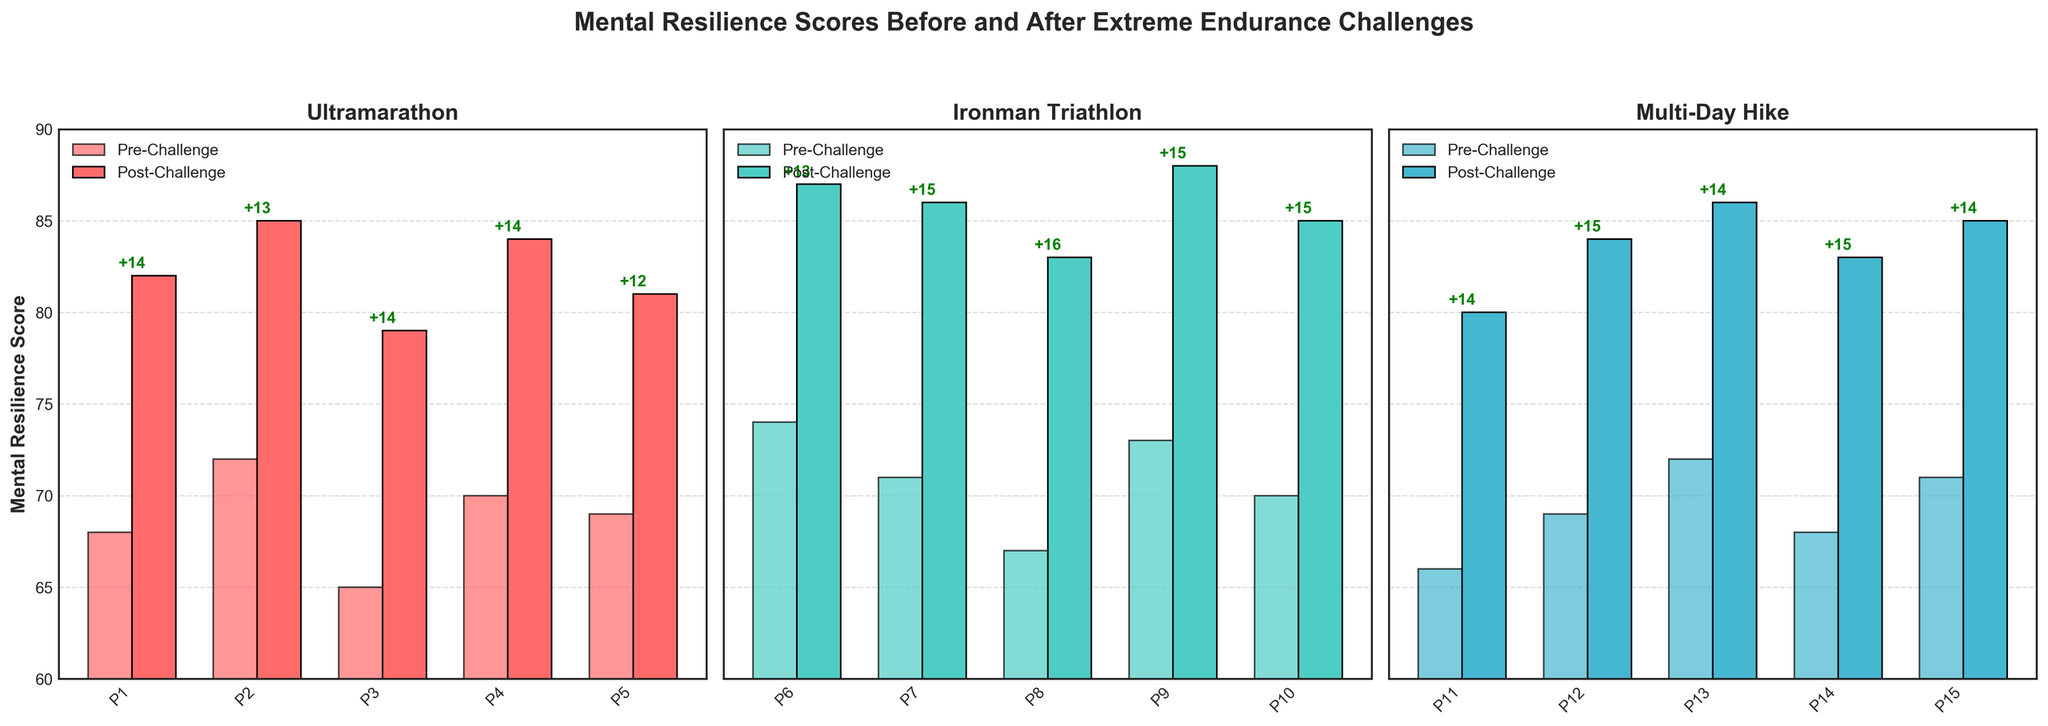Which challenge type showed the highest average improvement in mental resilience scores? First, calculate the improvement for each participant by subtracting the Pre-Challenge Score from the Post-Challenge Score. Then, find the average improvement for each challenge type. The highest average improvement will be the challenge with the largest mean increase. Ultramarathon: (82-68 + 85-72 + 79-65 + 84-70 + 81-69) / 5 = 13.8, Ironman Triathlon: (87-74 + 86-71 + 83-67 + 88-73 + 85-70) / 5 = 15.4, Multi-Day Hike: (80-66 + 84-69 + 86-72 + 83-68 + 85-71) / 5 = 13.6
Answer: Ironman Triathlon Which participant had the greatest increase in mental resilience score in the Ultramarathon challenge? Observe the 'Ultramarathon' subplot and compare the difference between Pre-Challenge and Post-Challenge scores for each participant. The participant with the highest increase is the one with the largest difference. Participants are P1: 14, P2: 13, P3: 14, P4: 14, P5: 12.
Answer: P1, P3, and P4 What is the total increase in mental resilience scores for participants in the Multi-Day Hike challenge? For each participant in the Multi-Day Hike challenge, calculate the difference between the Post-Challenge and Pre-Challenge scores, then sum these differences. (80-66) + (84-69) + (86-72) + (83-68) + (85-71) = 14 + 15 + 14 + 15 + 14 = 72
Answer: 72 Which challenge type had the smallest range of Pre-Challenge mental resilience scores among participants? Identify the range of Pre-Challenge scores for each challenge type, which is the difference between the maximum and minimum scores. Ultramarathon: Max(74), Min(65) -> Range: 9; Ironman Triathlon: Max(74), Min(67) -> Range: 7; Multi-Day Hike: Max(72), Min(66) -> Range: 6.
Answer: Multi-Day Hike Did any participant's mental resilience score decrease after the challenge? For each subgroup in the subplots, compare the Pre-Challenge and Post-Challenge scores. A decrease would be indicated if the Post-Challenge bar is shorter than the Pre-Challenge bar. None of the participants' scores decreased.
Answer: No Which challenge type has the most uniform improvement in mental resilience scores? Uniform improvement implies that the difference between Pre-Challenge and Post-Challenge scores is similar for all participants within a challenge type. Comparing the differences within each challenge type, consistency can be observed. Ultramarathon has variations (12-14), Ironman Triathlon has variations (13-17), Multi-Day Hike almost consistent (14-15).
Answer: Multi-Day Hike What is the median Post-Challenge mental resilience score for participants in the Ironman Triathlon? To find the median, list the Post-Challenge scores in ascending order and choose the middle value. Ironman Triathlon post-scores: 83, 85, 86, 87, 88; median is the middle value in the sorted list.
Answer: 86 In which challenge type did the participant with ID P10 take part? Locate participant P10's data in the subplots by checking each challenge type for their ID. P10 is listed under Ironman Triathlon.
Answer: Ironman Triathlon 